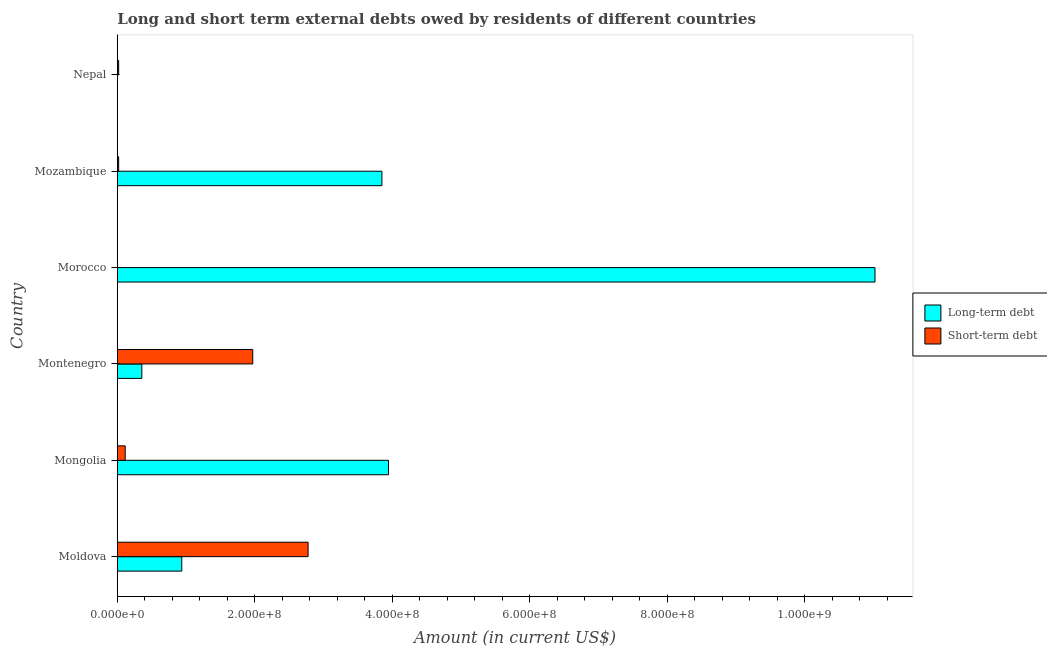How many different coloured bars are there?
Provide a short and direct response. 2. Are the number of bars per tick equal to the number of legend labels?
Your response must be concise. No. Are the number of bars on each tick of the Y-axis equal?
Provide a short and direct response. No. How many bars are there on the 4th tick from the top?
Offer a very short reply. 2. What is the label of the 1st group of bars from the top?
Make the answer very short. Nepal. In how many cases, is the number of bars for a given country not equal to the number of legend labels?
Make the answer very short. 2. What is the short-term debts owed by residents in Montenegro?
Keep it short and to the point. 1.97e+08. Across all countries, what is the maximum short-term debts owed by residents?
Your answer should be very brief. 2.77e+08. In which country was the short-term debts owed by residents maximum?
Offer a terse response. Moldova. What is the total short-term debts owed by residents in the graph?
Provide a succinct answer. 4.90e+08. What is the difference between the long-term debts owed by residents in Moldova and that in Morocco?
Ensure brevity in your answer.  -1.01e+09. What is the difference between the long-term debts owed by residents in Mozambique and the short-term debts owed by residents in Montenegro?
Give a very brief answer. 1.88e+08. What is the average short-term debts owed by residents per country?
Offer a very short reply. 8.17e+07. What is the difference between the long-term debts owed by residents and short-term debts owed by residents in Montenegro?
Make the answer very short. -1.61e+08. In how many countries, is the short-term debts owed by residents greater than 1000000000 US$?
Ensure brevity in your answer.  0. What is the ratio of the short-term debts owed by residents in Mozambique to that in Nepal?
Keep it short and to the point. 1. Is the long-term debts owed by residents in Mongolia less than that in Mozambique?
Give a very brief answer. No. What is the difference between the highest and the second highest short-term debts owed by residents?
Keep it short and to the point. 8.05e+07. What is the difference between the highest and the lowest long-term debts owed by residents?
Provide a succinct answer. 1.10e+09. In how many countries, is the long-term debts owed by residents greater than the average long-term debts owed by residents taken over all countries?
Ensure brevity in your answer.  3. How many bars are there?
Provide a succinct answer. 10. What is the difference between two consecutive major ticks on the X-axis?
Keep it short and to the point. 2.00e+08. Does the graph contain grids?
Make the answer very short. No. Where does the legend appear in the graph?
Your answer should be compact. Center right. What is the title of the graph?
Provide a short and direct response. Long and short term external debts owed by residents of different countries. What is the Amount (in current US$) of Long-term debt in Moldova?
Make the answer very short. 9.38e+07. What is the Amount (in current US$) of Short-term debt in Moldova?
Make the answer very short. 2.77e+08. What is the Amount (in current US$) in Long-term debt in Mongolia?
Ensure brevity in your answer.  3.94e+08. What is the Amount (in current US$) in Short-term debt in Mongolia?
Provide a short and direct response. 1.15e+07. What is the Amount (in current US$) of Long-term debt in Montenegro?
Make the answer very short. 3.57e+07. What is the Amount (in current US$) of Short-term debt in Montenegro?
Keep it short and to the point. 1.97e+08. What is the Amount (in current US$) of Long-term debt in Morocco?
Give a very brief answer. 1.10e+09. What is the Amount (in current US$) of Short-term debt in Morocco?
Your answer should be compact. 0. What is the Amount (in current US$) in Long-term debt in Mozambique?
Keep it short and to the point. 3.85e+08. What is the Amount (in current US$) of Short-term debt in Nepal?
Make the answer very short. 2.00e+06. Across all countries, what is the maximum Amount (in current US$) in Long-term debt?
Give a very brief answer. 1.10e+09. Across all countries, what is the maximum Amount (in current US$) of Short-term debt?
Offer a terse response. 2.77e+08. Across all countries, what is the minimum Amount (in current US$) of Long-term debt?
Your answer should be compact. 0. Across all countries, what is the minimum Amount (in current US$) of Short-term debt?
Offer a very short reply. 0. What is the total Amount (in current US$) of Long-term debt in the graph?
Ensure brevity in your answer.  2.01e+09. What is the total Amount (in current US$) of Short-term debt in the graph?
Keep it short and to the point. 4.90e+08. What is the difference between the Amount (in current US$) of Long-term debt in Moldova and that in Mongolia?
Offer a terse response. -3.01e+08. What is the difference between the Amount (in current US$) in Short-term debt in Moldova and that in Mongolia?
Your response must be concise. 2.66e+08. What is the difference between the Amount (in current US$) of Long-term debt in Moldova and that in Montenegro?
Provide a short and direct response. 5.81e+07. What is the difference between the Amount (in current US$) of Short-term debt in Moldova and that in Montenegro?
Offer a terse response. 8.05e+07. What is the difference between the Amount (in current US$) of Long-term debt in Moldova and that in Morocco?
Your answer should be compact. -1.01e+09. What is the difference between the Amount (in current US$) in Long-term debt in Moldova and that in Mozambique?
Your answer should be compact. -2.91e+08. What is the difference between the Amount (in current US$) of Short-term debt in Moldova and that in Mozambique?
Your answer should be very brief. 2.75e+08. What is the difference between the Amount (in current US$) of Short-term debt in Moldova and that in Nepal?
Provide a succinct answer. 2.75e+08. What is the difference between the Amount (in current US$) in Long-term debt in Mongolia and that in Montenegro?
Ensure brevity in your answer.  3.59e+08. What is the difference between the Amount (in current US$) of Short-term debt in Mongolia and that in Montenegro?
Offer a terse response. -1.85e+08. What is the difference between the Amount (in current US$) of Long-term debt in Mongolia and that in Morocco?
Provide a short and direct response. -7.08e+08. What is the difference between the Amount (in current US$) of Long-term debt in Mongolia and that in Mozambique?
Your response must be concise. 9.54e+06. What is the difference between the Amount (in current US$) of Short-term debt in Mongolia and that in Mozambique?
Your response must be concise. 9.52e+06. What is the difference between the Amount (in current US$) of Short-term debt in Mongolia and that in Nepal?
Make the answer very short. 9.52e+06. What is the difference between the Amount (in current US$) in Long-term debt in Montenegro and that in Morocco?
Ensure brevity in your answer.  -1.07e+09. What is the difference between the Amount (in current US$) in Long-term debt in Montenegro and that in Mozambique?
Offer a very short reply. -3.49e+08. What is the difference between the Amount (in current US$) in Short-term debt in Montenegro and that in Mozambique?
Your answer should be compact. 1.95e+08. What is the difference between the Amount (in current US$) of Short-term debt in Montenegro and that in Nepal?
Make the answer very short. 1.95e+08. What is the difference between the Amount (in current US$) in Long-term debt in Morocco and that in Mozambique?
Offer a very short reply. 7.17e+08. What is the difference between the Amount (in current US$) of Long-term debt in Moldova and the Amount (in current US$) of Short-term debt in Mongolia?
Provide a succinct answer. 8.22e+07. What is the difference between the Amount (in current US$) in Long-term debt in Moldova and the Amount (in current US$) in Short-term debt in Montenegro?
Offer a terse response. -1.03e+08. What is the difference between the Amount (in current US$) in Long-term debt in Moldova and the Amount (in current US$) in Short-term debt in Mozambique?
Your answer should be very brief. 9.18e+07. What is the difference between the Amount (in current US$) of Long-term debt in Moldova and the Amount (in current US$) of Short-term debt in Nepal?
Offer a very short reply. 9.18e+07. What is the difference between the Amount (in current US$) in Long-term debt in Mongolia and the Amount (in current US$) in Short-term debt in Montenegro?
Your answer should be compact. 1.97e+08. What is the difference between the Amount (in current US$) in Long-term debt in Mongolia and the Amount (in current US$) in Short-term debt in Mozambique?
Offer a very short reply. 3.92e+08. What is the difference between the Amount (in current US$) in Long-term debt in Mongolia and the Amount (in current US$) in Short-term debt in Nepal?
Your response must be concise. 3.92e+08. What is the difference between the Amount (in current US$) in Long-term debt in Montenegro and the Amount (in current US$) in Short-term debt in Mozambique?
Give a very brief answer. 3.37e+07. What is the difference between the Amount (in current US$) of Long-term debt in Montenegro and the Amount (in current US$) of Short-term debt in Nepal?
Offer a terse response. 3.37e+07. What is the difference between the Amount (in current US$) of Long-term debt in Morocco and the Amount (in current US$) of Short-term debt in Mozambique?
Your answer should be very brief. 1.10e+09. What is the difference between the Amount (in current US$) in Long-term debt in Morocco and the Amount (in current US$) in Short-term debt in Nepal?
Keep it short and to the point. 1.10e+09. What is the difference between the Amount (in current US$) in Long-term debt in Mozambique and the Amount (in current US$) in Short-term debt in Nepal?
Give a very brief answer. 3.83e+08. What is the average Amount (in current US$) in Long-term debt per country?
Offer a very short reply. 3.35e+08. What is the average Amount (in current US$) of Short-term debt per country?
Provide a succinct answer. 8.17e+07. What is the difference between the Amount (in current US$) in Long-term debt and Amount (in current US$) in Short-term debt in Moldova?
Keep it short and to the point. -1.84e+08. What is the difference between the Amount (in current US$) in Long-term debt and Amount (in current US$) in Short-term debt in Mongolia?
Provide a short and direct response. 3.83e+08. What is the difference between the Amount (in current US$) of Long-term debt and Amount (in current US$) of Short-term debt in Montenegro?
Give a very brief answer. -1.61e+08. What is the difference between the Amount (in current US$) of Long-term debt and Amount (in current US$) of Short-term debt in Mozambique?
Your response must be concise. 3.83e+08. What is the ratio of the Amount (in current US$) in Long-term debt in Moldova to that in Mongolia?
Provide a short and direct response. 0.24. What is the ratio of the Amount (in current US$) in Short-term debt in Moldova to that in Mongolia?
Your answer should be compact. 24.09. What is the ratio of the Amount (in current US$) of Long-term debt in Moldova to that in Montenegro?
Provide a succinct answer. 2.63. What is the ratio of the Amount (in current US$) of Short-term debt in Moldova to that in Montenegro?
Provide a short and direct response. 1.41. What is the ratio of the Amount (in current US$) in Long-term debt in Moldova to that in Morocco?
Keep it short and to the point. 0.09. What is the ratio of the Amount (in current US$) in Long-term debt in Moldova to that in Mozambique?
Give a very brief answer. 0.24. What is the ratio of the Amount (in current US$) in Short-term debt in Moldova to that in Mozambique?
Keep it short and to the point. 138.75. What is the ratio of the Amount (in current US$) in Short-term debt in Moldova to that in Nepal?
Your answer should be compact. 138.75. What is the ratio of the Amount (in current US$) of Long-term debt in Mongolia to that in Montenegro?
Your response must be concise. 11.05. What is the ratio of the Amount (in current US$) of Short-term debt in Mongolia to that in Montenegro?
Keep it short and to the point. 0.06. What is the ratio of the Amount (in current US$) of Long-term debt in Mongolia to that in Morocco?
Provide a short and direct response. 0.36. What is the ratio of the Amount (in current US$) of Long-term debt in Mongolia to that in Mozambique?
Your answer should be compact. 1.02. What is the ratio of the Amount (in current US$) in Short-term debt in Mongolia to that in Mozambique?
Make the answer very short. 5.76. What is the ratio of the Amount (in current US$) of Short-term debt in Mongolia to that in Nepal?
Provide a short and direct response. 5.76. What is the ratio of the Amount (in current US$) in Long-term debt in Montenegro to that in Morocco?
Give a very brief answer. 0.03. What is the ratio of the Amount (in current US$) of Long-term debt in Montenegro to that in Mozambique?
Make the answer very short. 0.09. What is the ratio of the Amount (in current US$) in Short-term debt in Montenegro to that in Mozambique?
Your answer should be very brief. 98.5. What is the ratio of the Amount (in current US$) in Short-term debt in Montenegro to that in Nepal?
Make the answer very short. 98.5. What is the ratio of the Amount (in current US$) of Long-term debt in Morocco to that in Mozambique?
Offer a very short reply. 2.86. What is the difference between the highest and the second highest Amount (in current US$) in Long-term debt?
Give a very brief answer. 7.08e+08. What is the difference between the highest and the second highest Amount (in current US$) of Short-term debt?
Provide a short and direct response. 8.05e+07. What is the difference between the highest and the lowest Amount (in current US$) in Long-term debt?
Keep it short and to the point. 1.10e+09. What is the difference between the highest and the lowest Amount (in current US$) in Short-term debt?
Your answer should be very brief. 2.77e+08. 